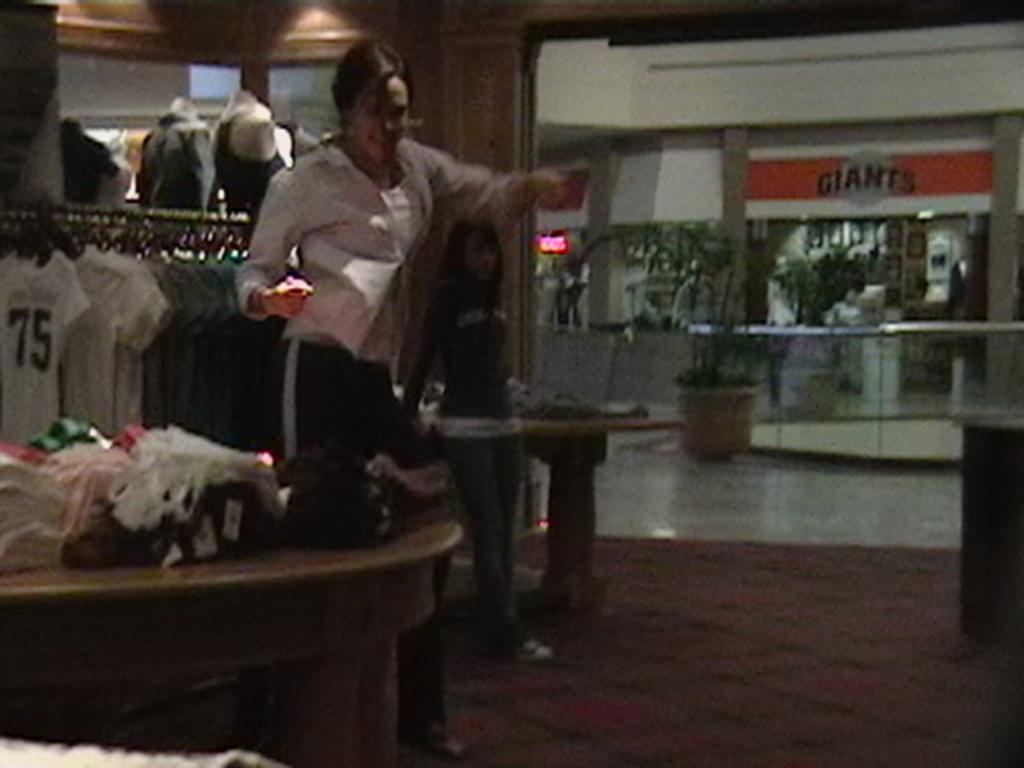Could you give a brief overview of what you see in this image? A woman is standing in cloth store with few garments in front of her on a table and few behind her hanged to the bar. And there are few mannequins. There is girl behind her standing. 